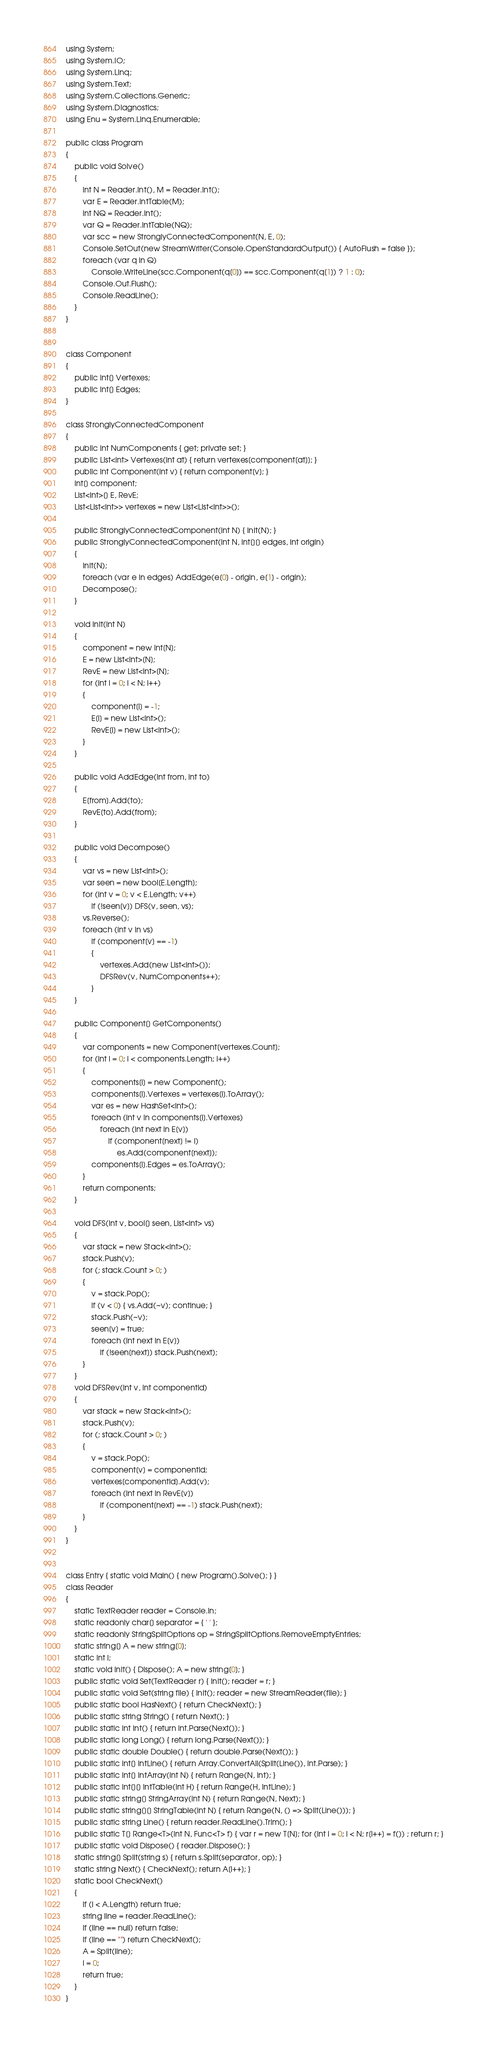Convert code to text. <code><loc_0><loc_0><loc_500><loc_500><_C#_>using System;
using System.IO;
using System.Linq;
using System.Text;
using System.Collections.Generic;
using System.Diagnostics;
using Enu = System.Linq.Enumerable;

public class Program
{
    public void Solve()
    {
        int N = Reader.Int(), M = Reader.Int();
        var E = Reader.IntTable(M);
        int NQ = Reader.Int();
        var Q = Reader.IntTable(NQ);
        var scc = new StronglyConnectedComponent(N, E, 0);
        Console.SetOut(new StreamWriter(Console.OpenStandardOutput()) { AutoFlush = false });
        foreach (var q in Q)
            Console.WriteLine(scc.Component(q[0]) == scc.Component(q[1]) ? 1 : 0);
        Console.Out.Flush();
        Console.ReadLine();
    }
}


class Component
{
    public int[] Vertexes;
    public int[] Edges;
}

class StronglyConnectedComponent
{
    public int NumComponents { get; private set; }
    public List<int> Vertexes(int at) { return vertexes[component[at]]; }
    public int Component(int v) { return component[v]; }
    int[] component;
    List<int>[] E, RevE;
    List<List<int>> vertexes = new List<List<int>>();

    public StronglyConnectedComponent(int N) { Init(N); }
    public StronglyConnectedComponent(int N, int[][] edges, int origin)
    {
        Init(N);
        foreach (var e in edges) AddEdge(e[0] - origin, e[1] - origin);
        Decompose();
    }

    void Init(int N)
    {
        component = new int[N];
        E = new List<int>[N];
        RevE = new List<int>[N];
        for (int i = 0; i < N; i++)
        {
            component[i] = -1;
            E[i] = new List<int>();
            RevE[i] = new List<int>();
        }
    }

    public void AddEdge(int from, int to)
    {
        E[from].Add(to);
        RevE[to].Add(from);
    }

    public void Decompose()
    {
        var vs = new List<int>();
        var seen = new bool[E.Length];
        for (int v = 0; v < E.Length; v++)
            if (!seen[v]) DFS(v, seen, vs);
        vs.Reverse();
        foreach (int v in vs)
            if (component[v] == -1)
            {
                vertexes.Add(new List<int>());
                DFSRev(v, NumComponents++);
            }
    }

    public Component[] GetComponents()
    {
        var components = new Component[vertexes.Count];
        for (int i = 0; i < components.Length; i++)
        {
            components[i] = new Component();
            components[i].Vertexes = vertexes[i].ToArray();
            var es = new HashSet<int>();
            foreach (int v in components[i].Vertexes)
                foreach (int next in E[v])
                    if (component[next] != i)
                        es.Add(component[next]);
            components[i].Edges = es.ToArray();
        }
        return components;
    }

    void DFS(int v, bool[] seen, List<int> vs)
    {
        var stack = new Stack<int>();
        stack.Push(v);
        for (; stack.Count > 0; )
        {
            v = stack.Pop();
            if (v < 0) { vs.Add(~v); continue; }
            stack.Push(~v);
            seen[v] = true;
            foreach (int next in E[v])
                if (!seen[next]) stack.Push(next);
        }
    }
    void DFSRev(int v, int componentId)
    {
        var stack = new Stack<int>();
        stack.Push(v);
        for (; stack.Count > 0; )
        {
            v = stack.Pop();
            component[v] = componentId;
            vertexes[componentId].Add(v);
            foreach (int next in RevE[v])
                if (component[next] == -1) stack.Push(next);
        }
    }
}


class Entry { static void Main() { new Program().Solve(); } }
class Reader
{
    static TextReader reader = Console.In;
    static readonly char[] separator = { ' ' };
    static readonly StringSplitOptions op = StringSplitOptions.RemoveEmptyEntries;
    static string[] A = new string[0];
    static int i;
    static void Init() { Dispose(); A = new string[0]; }
    public static void Set(TextReader r) { Init(); reader = r; }
    public static void Set(string file) { Init(); reader = new StreamReader(file); }
    public static bool HasNext() { return CheckNext(); }
    public static string String() { return Next(); }
    public static int Int() { return int.Parse(Next()); }
    public static long Long() { return long.Parse(Next()); }
    public static double Double() { return double.Parse(Next()); }
    public static int[] IntLine() { return Array.ConvertAll(Split(Line()), int.Parse); }
    public static int[] IntArray(int N) { return Range(N, Int); }
    public static int[][] IntTable(int H) { return Range(H, IntLine); }
    public static string[] StringArray(int N) { return Range(N, Next); }
    public static string[][] StringTable(int N) { return Range(N, () => Split(Line())); }
    public static string Line() { return reader.ReadLine().Trim(); }
    public static T[] Range<T>(int N, Func<T> f) { var r = new T[N]; for (int i = 0; i < N; r[i++] = f()) ; return r; }
    public static void Dispose() { reader.Dispose(); }
    static string[] Split(string s) { return s.Split(separator, op); }
    static string Next() { CheckNext(); return A[i++]; }
    static bool CheckNext()
    {
        if (i < A.Length) return true;
        string line = reader.ReadLine();
        if (line == null) return false;
        if (line == "") return CheckNext();
        A = Split(line);
        i = 0;
        return true;
    }
}</code> 